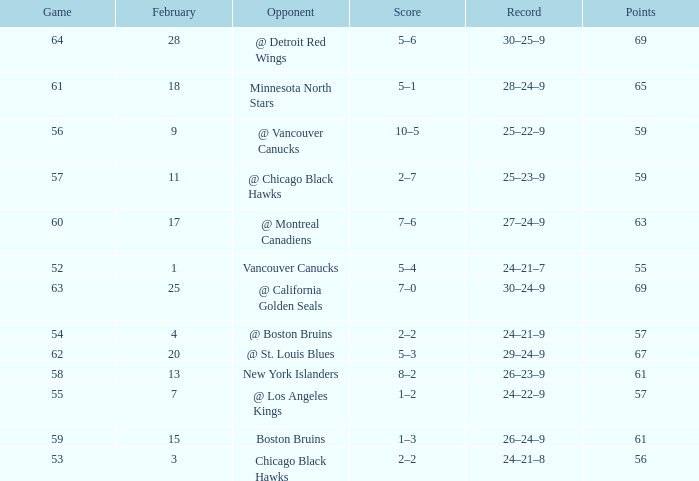Could you parse the entire table as a dict? {'header': ['Game', 'February', 'Opponent', 'Score', 'Record', 'Points'], 'rows': [['64', '28', '@ Detroit Red Wings', '5–6', '30–25–9', '69'], ['61', '18', 'Minnesota North Stars', '5–1', '28–24–9', '65'], ['56', '9', '@ Vancouver Canucks', '10–5', '25–22–9', '59'], ['57', '11', '@ Chicago Black Hawks', '2–7', '25–23–9', '59'], ['60', '17', '@ Montreal Canadiens', '7–6', '27–24–9', '63'], ['52', '1', 'Vancouver Canucks', '5–4', '24–21–7', '55'], ['63', '25', '@ California Golden Seals', '7–0', '30–24–9', '69'], ['54', '4', '@ Boston Bruins', '2–2', '24–21–9', '57'], ['62', '20', '@ St. Louis Blues', '5–3', '29–24–9', '67'], ['58', '13', 'New York Islanders', '8–2', '26–23–9', '61'], ['55', '7', '@ Los Angeles Kings', '1–2', '24–22–9', '57'], ['59', '15', 'Boston Bruins', '1–3', '26–24–9', '61'], ['53', '3', 'Chicago Black Hawks', '2–2', '24–21–8', '56']]} How many february games had a record of 29–24–9? 20.0. 